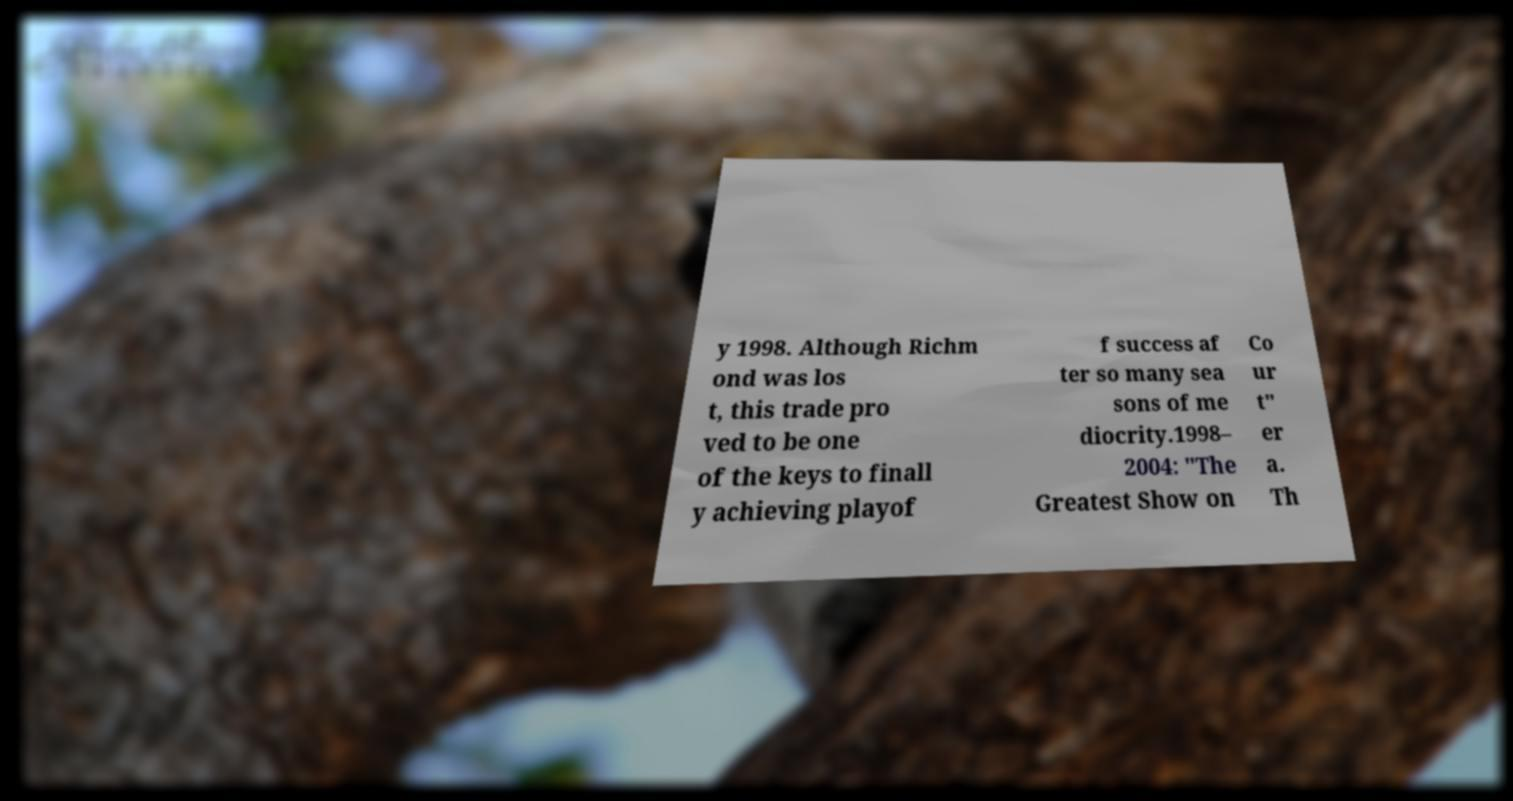Could you assist in decoding the text presented in this image and type it out clearly? y 1998. Although Richm ond was los t, this trade pro ved to be one of the keys to finall y achieving playof f success af ter so many sea sons of me diocrity.1998– 2004: "The Greatest Show on Co ur t" er a. Th 